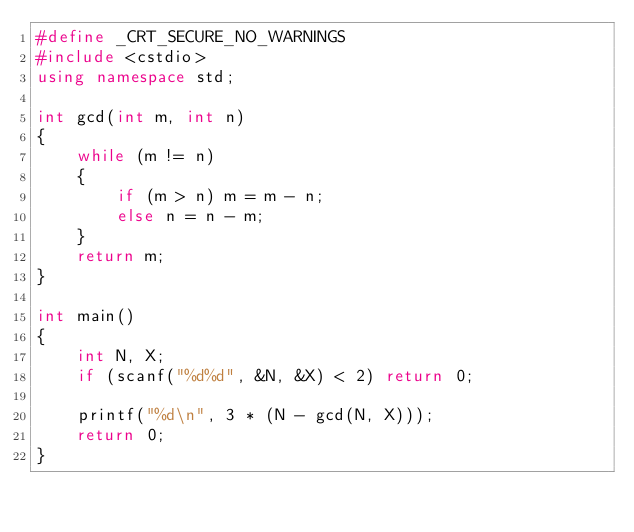Convert code to text. <code><loc_0><loc_0><loc_500><loc_500><_C++_>#define _CRT_SECURE_NO_WARNINGS
#include <cstdio>
using namespace std;

int gcd(int m, int n)
{
    while (m != n)
    {
        if (m > n) m = m - n;
        else n = n - m;
    }
    return m;
}

int main()
{
    int N, X;
    if (scanf("%d%d", &N, &X) < 2) return 0;

    printf("%d\n", 3 * (N - gcd(N, X)));
    return 0;
}
</code> 